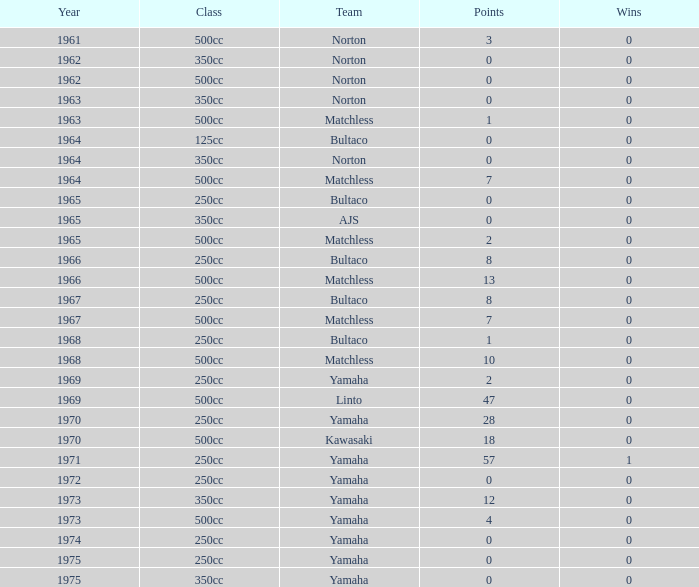Can you give me this table as a dict? {'header': ['Year', 'Class', 'Team', 'Points', 'Wins'], 'rows': [['1961', '500cc', 'Norton', '3', '0'], ['1962', '350cc', 'Norton', '0', '0'], ['1962', '500cc', 'Norton', '0', '0'], ['1963', '350cc', 'Norton', '0', '0'], ['1963', '500cc', 'Matchless', '1', '0'], ['1964', '125cc', 'Bultaco', '0', '0'], ['1964', '350cc', 'Norton', '0', '0'], ['1964', '500cc', 'Matchless', '7', '0'], ['1965', '250cc', 'Bultaco', '0', '0'], ['1965', '350cc', 'AJS', '0', '0'], ['1965', '500cc', 'Matchless', '2', '0'], ['1966', '250cc', 'Bultaco', '8', '0'], ['1966', '500cc', 'Matchless', '13', '0'], ['1967', '250cc', 'Bultaco', '8', '0'], ['1967', '500cc', 'Matchless', '7', '0'], ['1968', '250cc', 'Bultaco', '1', '0'], ['1968', '500cc', 'Matchless', '10', '0'], ['1969', '250cc', 'Yamaha', '2', '0'], ['1969', '500cc', 'Linto', '47', '0'], ['1970', '250cc', 'Yamaha', '28', '0'], ['1970', '500cc', 'Kawasaki', '18', '0'], ['1971', '250cc', 'Yamaha', '57', '1'], ['1972', '250cc', 'Yamaha', '0', '0'], ['1973', '350cc', 'Yamaha', '12', '0'], ['1973', '500cc', 'Yamaha', '4', '0'], ['1974', '250cc', 'Yamaha', '0', '0'], ['1975', '250cc', 'Yamaha', '0', '0'], ['1975', '350cc', 'Yamaha', '0', '0']]} Which class corresponds to more than 2 points, wins greater than 0, and a year earlier than 1973? 250cc. 